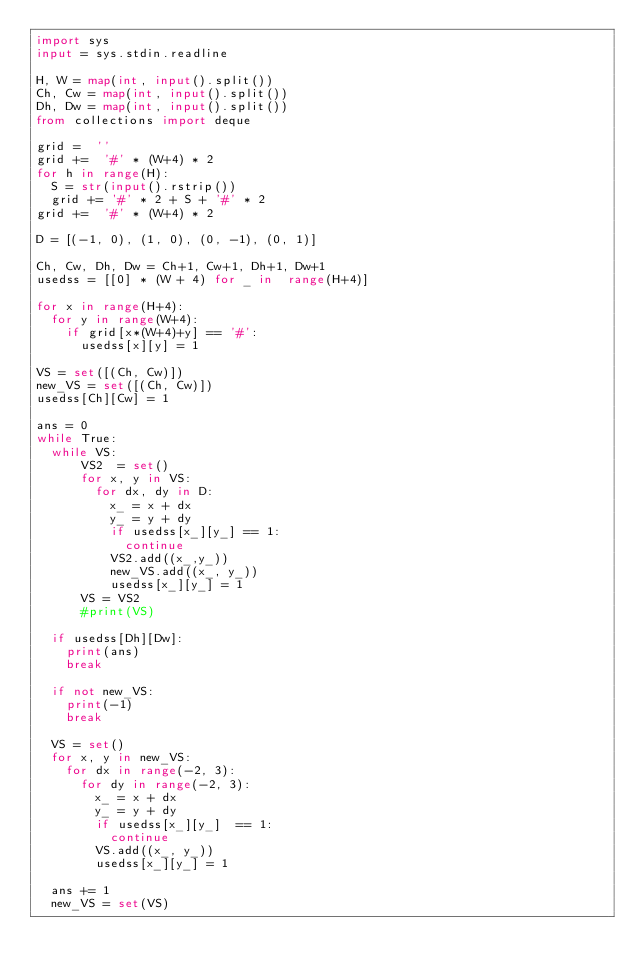Convert code to text. <code><loc_0><loc_0><loc_500><loc_500><_Python_>import sys
input = sys.stdin.readline

H, W = map(int, input().split())
Ch, Cw = map(int, input().split())
Dh, Dw = map(int, input().split())
from collections import deque

grid =  ''
grid +=  '#' * (W+4) * 2
for h in range(H):
  S = str(input().rstrip())
  grid += '#' * 2 + S + '#' * 2
grid +=  '#' * (W+4) * 2

D = [(-1, 0), (1, 0), (0, -1), (0, 1)]

Ch, Cw, Dh, Dw = Ch+1, Cw+1, Dh+1, Dw+1
usedss = [[0] * (W + 4) for _ in  range(H+4)]
      
for x in range(H+4):
  for y in range(W+4):
    if grid[x*(W+4)+y] == '#':
      usedss[x][y] = 1
      
VS = set([(Ch, Cw)])
new_VS = set([(Ch, Cw)])
usedss[Ch][Cw] = 1
      
ans = 0
while True:
  while VS:
      VS2  = set()
      for x, y in VS:
        for dx, dy in D:
          x_ = x + dx
          y_ = y + dy
          if usedss[x_][y_] == 1:
            continue
          VS2.add((x_,y_))
          new_VS.add((x_, y_))
          usedss[x_][y_] = 1
      VS = VS2
      #print(VS)
      
  if usedss[Dh][Dw]:
    print(ans)
    break
    
  if not new_VS:
    print(-1)
    break
    
  VS = set()
  for x, y in new_VS:
    for dx in range(-2, 3):
      for dy in range(-2, 3):
        x_ = x + dx
        y_ = y + dy
        if usedss[x_][y_]  == 1:
          continue
        VS.add((x_, y_))
        usedss[x_][y_] = 1
        
  ans += 1
  new_VS = set(VS)</code> 